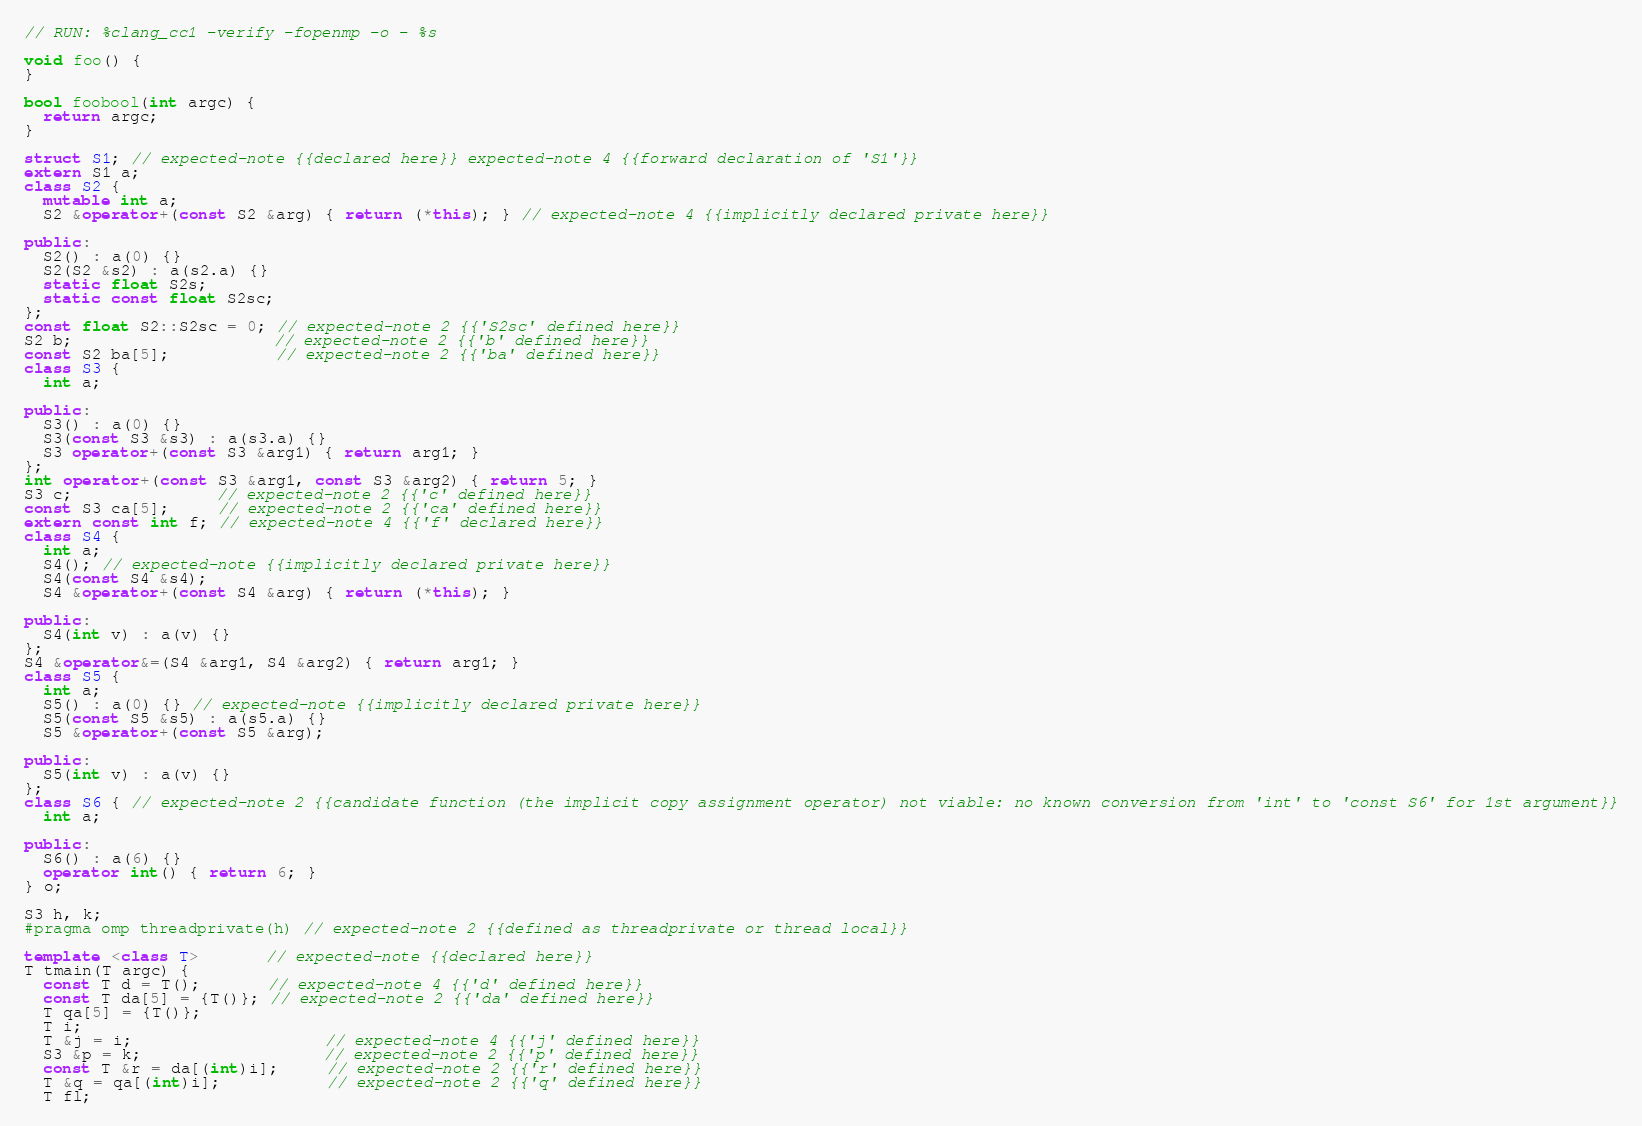<code> <loc_0><loc_0><loc_500><loc_500><_C++_>// RUN: %clang_cc1 -verify -fopenmp -o - %s

void foo() {
}

bool foobool(int argc) {
  return argc;
}

struct S1; // expected-note {{declared here}} expected-note 4 {{forward declaration of 'S1'}}
extern S1 a;
class S2 {
  mutable int a;
  S2 &operator+(const S2 &arg) { return (*this); } // expected-note 4 {{implicitly declared private here}}

public:
  S2() : a(0) {}
  S2(S2 &s2) : a(s2.a) {}
  static float S2s;
  static const float S2sc;
};
const float S2::S2sc = 0; // expected-note 2 {{'S2sc' defined here}}
S2 b;                     // expected-note 2 {{'b' defined here}}
const S2 ba[5];           // expected-note 2 {{'ba' defined here}}
class S3 {
  int a;

public:
  S3() : a(0) {}
  S3(const S3 &s3) : a(s3.a) {}
  S3 operator+(const S3 &arg1) { return arg1; }
};
int operator+(const S3 &arg1, const S3 &arg2) { return 5; }
S3 c;               // expected-note 2 {{'c' defined here}}
const S3 ca[5];     // expected-note 2 {{'ca' defined here}}
extern const int f; // expected-note 4 {{'f' declared here}}
class S4 {
  int a;
  S4(); // expected-note {{implicitly declared private here}}
  S4(const S4 &s4);
  S4 &operator+(const S4 &arg) { return (*this); }

public:
  S4(int v) : a(v) {}
};
S4 &operator&=(S4 &arg1, S4 &arg2) { return arg1; }
class S5 {
  int a;
  S5() : a(0) {} // expected-note {{implicitly declared private here}}
  S5(const S5 &s5) : a(s5.a) {}
  S5 &operator+(const S5 &arg);

public:
  S5(int v) : a(v) {}
};
class S6 { // expected-note 2 {{candidate function (the implicit copy assignment operator) not viable: no known conversion from 'int' to 'const S6' for 1st argument}}
  int a;

public:
  S6() : a(6) {}
  operator int() { return 6; }
} o;

S3 h, k;
#pragma omp threadprivate(h) // expected-note 2 {{defined as threadprivate or thread local}}

template <class T>       // expected-note {{declared here}}
T tmain(T argc) {
  const T d = T();       // expected-note 4 {{'d' defined here}}
  const T da[5] = {T()}; // expected-note 2 {{'da' defined here}}
  T qa[5] = {T()};
  T i;
  T &j = i;                    // expected-note 4 {{'j' defined here}}
  S3 &p = k;                   // expected-note 2 {{'p' defined here}}
  const T &r = da[(int)i];     // expected-note 2 {{'r' defined here}}
  T &q = qa[(int)i];           // expected-note 2 {{'q' defined here}}
  T fl;</code> 